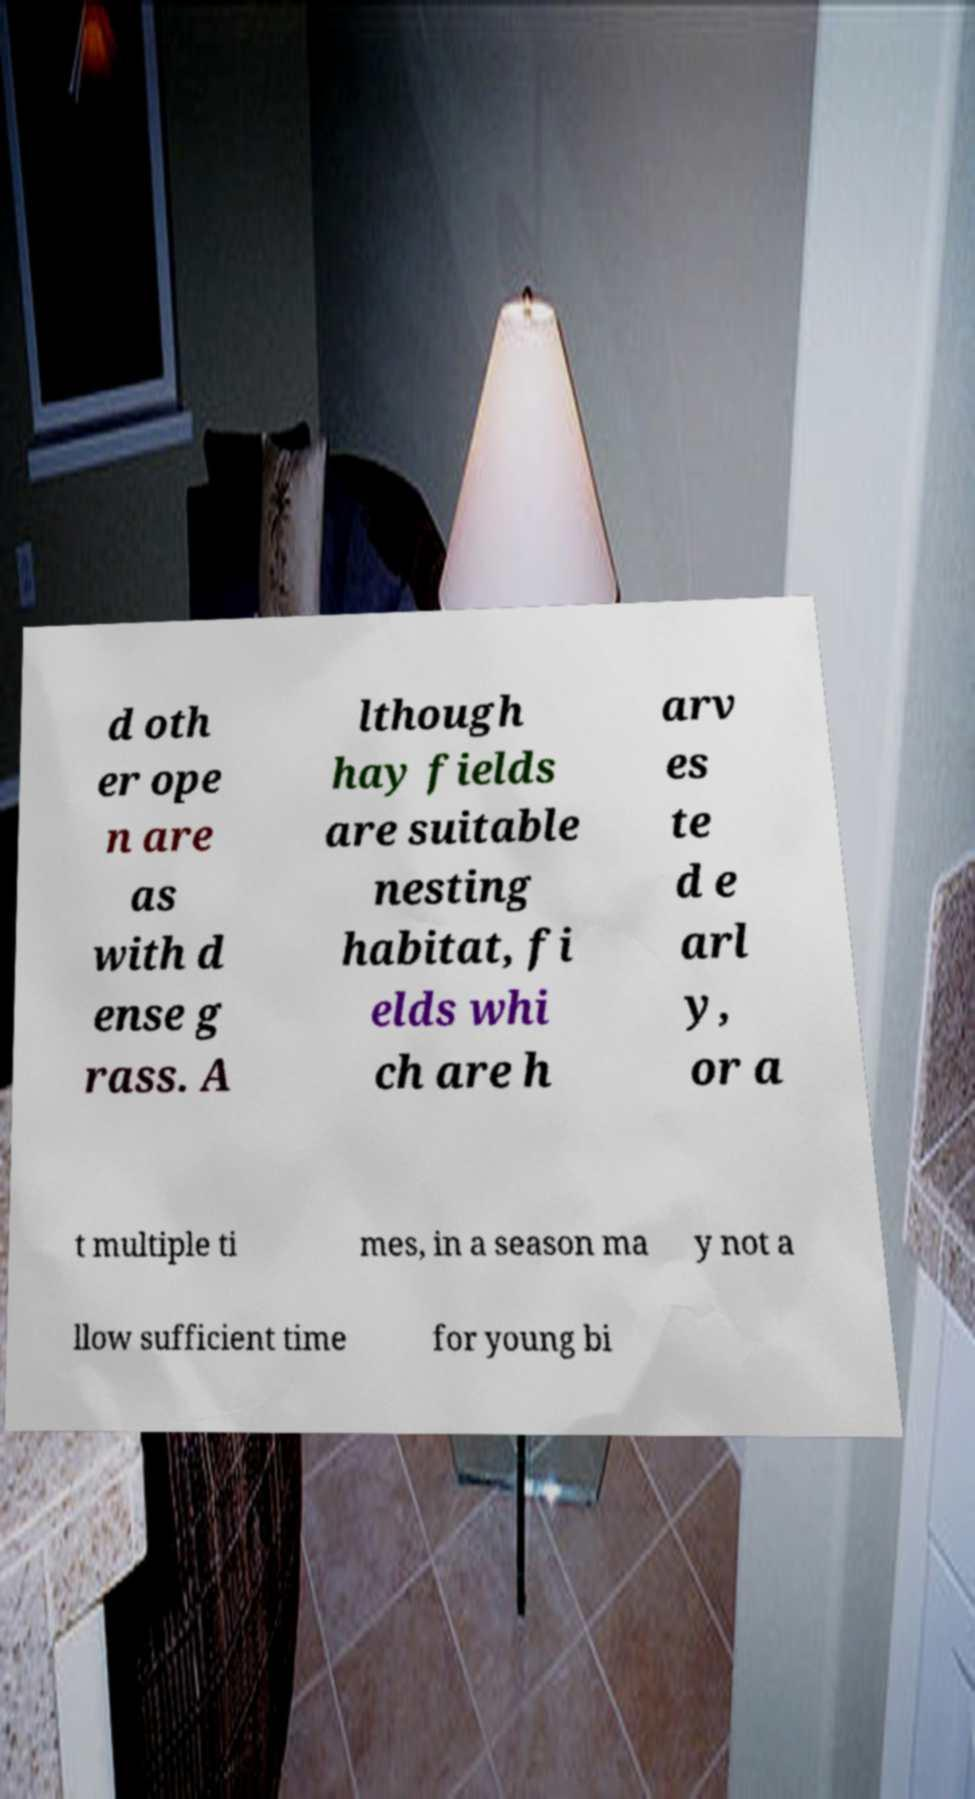What messages or text are displayed in this image? I need them in a readable, typed format. d oth er ope n are as with d ense g rass. A lthough hay fields are suitable nesting habitat, fi elds whi ch are h arv es te d e arl y, or a t multiple ti mes, in a season ma y not a llow sufficient time for young bi 